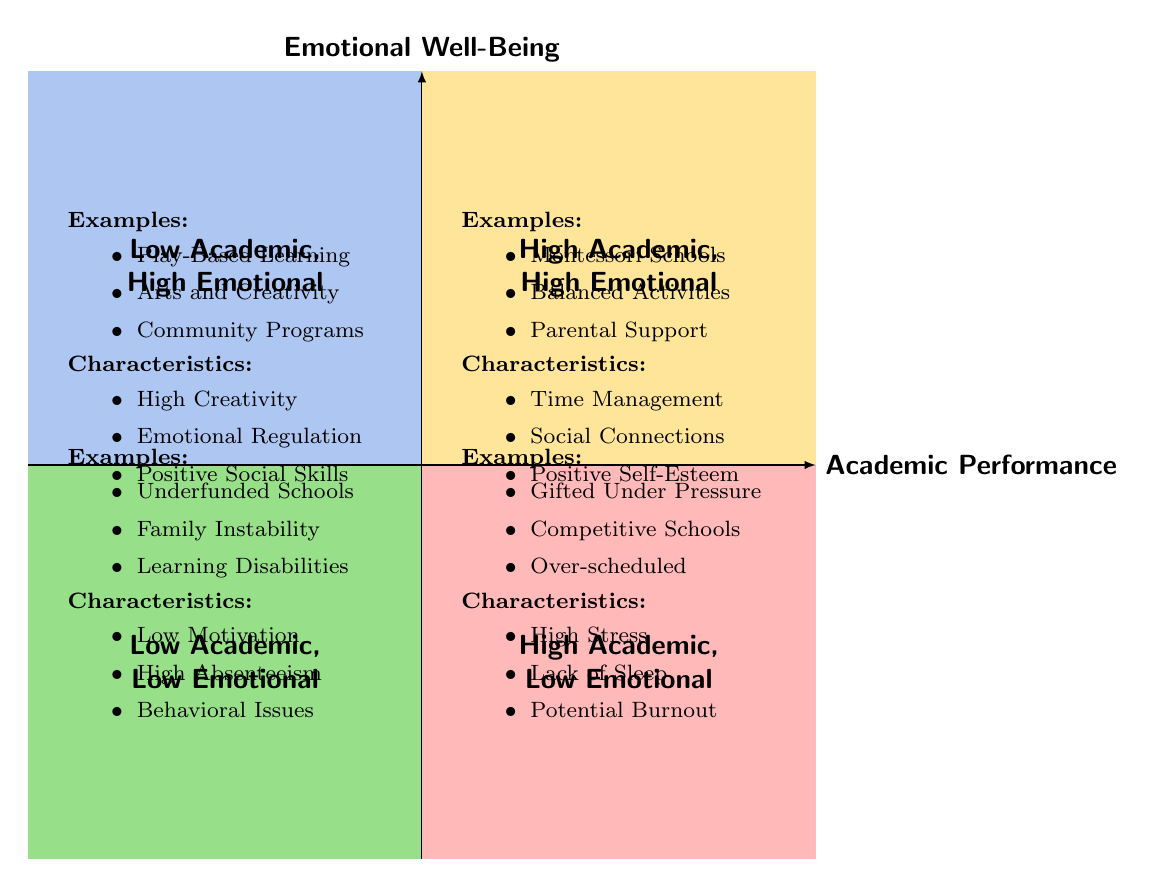What examples are listed in the "High Academic Performance, High Emotional Well-Being" quadrant? This quadrant includes examples such as "Students at Montessori Schools," "Children engaged in Balanced Extracurricular Activities," and "Pupils receiving Regular Parental Support." These specific instances are directly mentioned in the quadrant in the diagram.
Answer: Students at Montessori Schools, Children engaged in Balanced Extracurricular Activities, Pupils receiving Regular Parental Support What is a characteristic of children in the "Low Academic Performance, Low Emotional Well-Being" quadrant? One of the characteristics listed for this quadrant is "Low Motivation." It is a key attribute identified in the diagram for this specific group of children.
Answer: Low Motivation How many quadrants are depicted in the diagram? The diagram presents a total of four quadrants, each representing different combinations of academic performance and emotional well-being. This can be counted directly from the diagram sections.
Answer: Four In which quadrant would you find children experiencing family instability? Children experiencing family instability are included in the "Low Academic Performance, Low Emotional Well-Being" quadrant, as indicated directly in the examples section of that quadrant.
Answer: Low Academic Performance, Low Emotional Well-Being What is a common characteristic shared by children in both the "High Academic Performance, Low Emotional Well-Being" and "Low Academic Performance, Low Emotional Well-Being" quadrants? Both quadrants show a negative aspect: "High Stress Levels" for the former and "High Absenteeism" for the latter. However, they both indicate a problem; stress for the high achievers and absenteeism for those struggling academically.
Answer: Negative aspects Which quadrant features children with strong emotional regulation? The "Low Academic Performance, High Emotional Well-Being" quadrant lists "Strong Emotional Regulation" as one of its characteristics, signifying the positive emotional state despite low academic outcomes.
Answer: Low Academic Performance, High Emotional Well-Being What example in the "High Academic Performance, Low Emotional Well-Being" quadrant could lead to burnout? One such example provided in this quadrant is "Over-scheduled Children," indicating that excessive scheduling can contribute to the risk of burnout.
Answer: Over-scheduled Children Which quadrant contains the examples of "Students with Unaddressed Learning Disabilities"? This example can be found in the "Low Academic Performance, Low Emotional Well-Being" quadrant, which explicitly lists it among the challenges affecting these children.
Answer: Low Academic Performance, Low Emotional Well-Being 